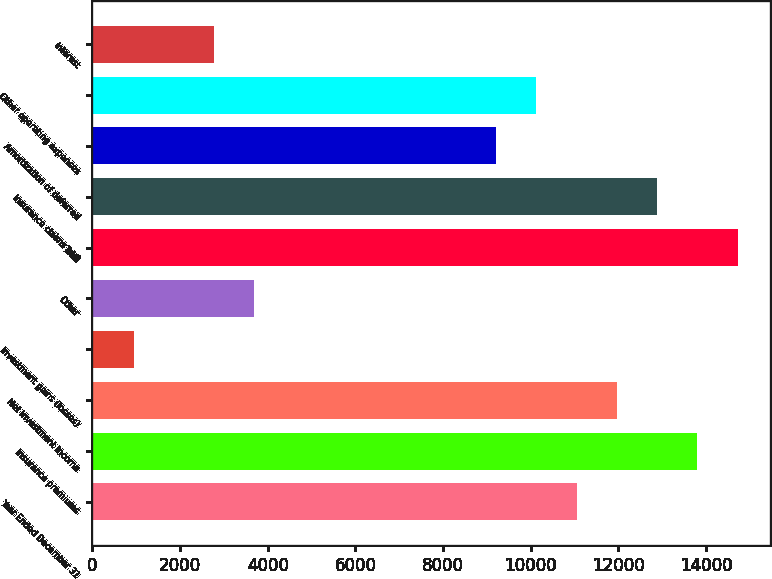<chart> <loc_0><loc_0><loc_500><loc_500><bar_chart><fcel>Year Ended December 31<fcel>Insurance premiums<fcel>Net investment income<fcel>Investment gains (losses)<fcel>Other<fcel>Total<fcel>Insurance claims and<fcel>Amortization of deferred<fcel>Other operating expenses<fcel>Interest<nl><fcel>11045.6<fcel>13802<fcel>11964.4<fcel>938.8<fcel>3695.2<fcel>14720.8<fcel>12883.2<fcel>9208<fcel>10126.8<fcel>2776.4<nl></chart> 